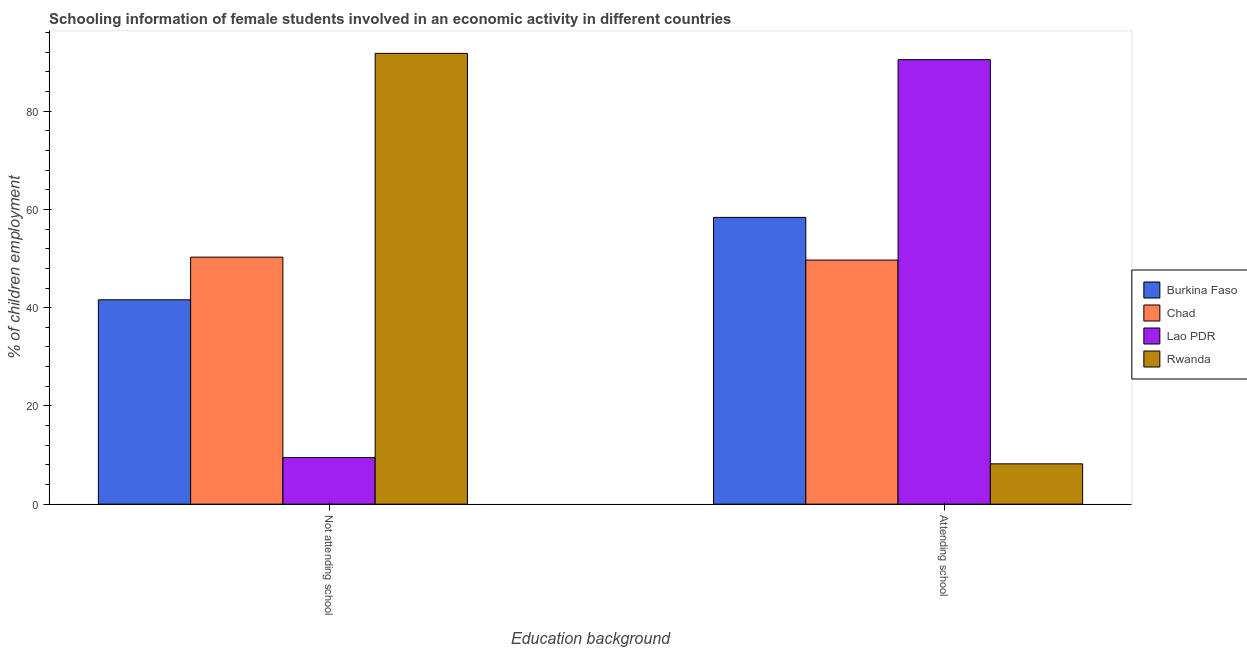How many groups of bars are there?
Ensure brevity in your answer.  2. Are the number of bars per tick equal to the number of legend labels?
Your answer should be compact. Yes. How many bars are there on the 1st tick from the left?
Give a very brief answer. 4. How many bars are there on the 2nd tick from the right?
Offer a very short reply. 4. What is the label of the 2nd group of bars from the left?
Ensure brevity in your answer.  Attending school. What is the percentage of employed females who are not attending school in Rwanda?
Provide a short and direct response. 91.79. Across all countries, what is the maximum percentage of employed females who are not attending school?
Offer a very short reply. 91.79. Across all countries, what is the minimum percentage of employed females who are not attending school?
Your answer should be very brief. 9.49. In which country was the percentage of employed females who are attending school maximum?
Your answer should be compact. Lao PDR. In which country was the percentage of employed females who are attending school minimum?
Offer a very short reply. Rwanda. What is the total percentage of employed females who are not attending school in the graph?
Make the answer very short. 193.19. What is the difference between the percentage of employed females who are not attending school in Chad and that in Lao PDR?
Keep it short and to the point. 40.81. What is the difference between the percentage of employed females who are not attending school in Rwanda and the percentage of employed females who are attending school in Chad?
Keep it short and to the point. 42.09. What is the average percentage of employed females who are not attending school per country?
Offer a terse response. 48.3. What is the difference between the percentage of employed females who are attending school and percentage of employed females who are not attending school in Rwanda?
Your answer should be compact. -83.58. What is the ratio of the percentage of employed females who are attending school in Chad to that in Burkina Faso?
Your answer should be very brief. 0.85. Is the percentage of employed females who are attending school in Lao PDR less than that in Burkina Faso?
Your answer should be very brief. No. What does the 4th bar from the left in Not attending school represents?
Provide a succinct answer. Rwanda. What does the 1st bar from the right in Not attending school represents?
Give a very brief answer. Rwanda. How many countries are there in the graph?
Offer a terse response. 4. Does the graph contain grids?
Ensure brevity in your answer.  No. Where does the legend appear in the graph?
Provide a short and direct response. Center right. How are the legend labels stacked?
Keep it short and to the point. Vertical. What is the title of the graph?
Provide a short and direct response. Schooling information of female students involved in an economic activity in different countries. Does "Saudi Arabia" appear as one of the legend labels in the graph?
Give a very brief answer. No. What is the label or title of the X-axis?
Your response must be concise. Education background. What is the label or title of the Y-axis?
Your answer should be compact. % of children employment. What is the % of children employment of Burkina Faso in Not attending school?
Ensure brevity in your answer.  41.61. What is the % of children employment of Chad in Not attending school?
Your answer should be compact. 50.3. What is the % of children employment in Lao PDR in Not attending school?
Give a very brief answer. 9.49. What is the % of children employment in Rwanda in Not attending school?
Your response must be concise. 91.79. What is the % of children employment of Burkina Faso in Attending school?
Make the answer very short. 58.39. What is the % of children employment in Chad in Attending school?
Ensure brevity in your answer.  49.7. What is the % of children employment of Lao PDR in Attending school?
Your answer should be very brief. 90.51. What is the % of children employment of Rwanda in Attending school?
Make the answer very short. 8.21. Across all Education background, what is the maximum % of children employment of Burkina Faso?
Your answer should be very brief. 58.39. Across all Education background, what is the maximum % of children employment in Chad?
Make the answer very short. 50.3. Across all Education background, what is the maximum % of children employment of Lao PDR?
Your answer should be very brief. 90.51. Across all Education background, what is the maximum % of children employment in Rwanda?
Keep it short and to the point. 91.79. Across all Education background, what is the minimum % of children employment of Burkina Faso?
Your answer should be compact. 41.61. Across all Education background, what is the minimum % of children employment in Chad?
Provide a short and direct response. 49.7. Across all Education background, what is the minimum % of children employment of Lao PDR?
Provide a succinct answer. 9.49. Across all Education background, what is the minimum % of children employment in Rwanda?
Make the answer very short. 8.21. What is the total % of children employment in Burkina Faso in the graph?
Keep it short and to the point. 100. What is the total % of children employment in Chad in the graph?
Keep it short and to the point. 100. What is the difference between the % of children employment in Burkina Faso in Not attending school and that in Attending school?
Your answer should be compact. -16.78. What is the difference between the % of children employment in Lao PDR in Not attending school and that in Attending school?
Your response must be concise. -81.02. What is the difference between the % of children employment of Rwanda in Not attending school and that in Attending school?
Give a very brief answer. 83.58. What is the difference between the % of children employment of Burkina Faso in Not attending school and the % of children employment of Chad in Attending school?
Offer a terse response. -8.09. What is the difference between the % of children employment in Burkina Faso in Not attending school and the % of children employment in Lao PDR in Attending school?
Offer a very short reply. -48.9. What is the difference between the % of children employment of Burkina Faso in Not attending school and the % of children employment of Rwanda in Attending school?
Ensure brevity in your answer.  33.4. What is the difference between the % of children employment of Chad in Not attending school and the % of children employment of Lao PDR in Attending school?
Provide a short and direct response. -40.21. What is the difference between the % of children employment of Chad in Not attending school and the % of children employment of Rwanda in Attending school?
Keep it short and to the point. 42.09. What is the difference between the % of children employment in Lao PDR in Not attending school and the % of children employment in Rwanda in Attending school?
Your answer should be very brief. 1.28. What is the average % of children employment in Burkina Faso per Education background?
Provide a succinct answer. 50. What is the average % of children employment in Chad per Education background?
Your answer should be compact. 50. What is the difference between the % of children employment of Burkina Faso and % of children employment of Chad in Not attending school?
Make the answer very short. -8.69. What is the difference between the % of children employment of Burkina Faso and % of children employment of Lao PDR in Not attending school?
Make the answer very short. 32.12. What is the difference between the % of children employment in Burkina Faso and % of children employment in Rwanda in Not attending school?
Keep it short and to the point. -50.18. What is the difference between the % of children employment of Chad and % of children employment of Lao PDR in Not attending school?
Provide a short and direct response. 40.81. What is the difference between the % of children employment of Chad and % of children employment of Rwanda in Not attending school?
Your response must be concise. -41.49. What is the difference between the % of children employment in Lao PDR and % of children employment in Rwanda in Not attending school?
Your answer should be compact. -82.3. What is the difference between the % of children employment in Burkina Faso and % of children employment in Chad in Attending school?
Ensure brevity in your answer.  8.69. What is the difference between the % of children employment in Burkina Faso and % of children employment in Lao PDR in Attending school?
Make the answer very short. -32.12. What is the difference between the % of children employment of Burkina Faso and % of children employment of Rwanda in Attending school?
Keep it short and to the point. 50.18. What is the difference between the % of children employment in Chad and % of children employment in Lao PDR in Attending school?
Keep it short and to the point. -40.81. What is the difference between the % of children employment of Chad and % of children employment of Rwanda in Attending school?
Give a very brief answer. 41.49. What is the difference between the % of children employment of Lao PDR and % of children employment of Rwanda in Attending school?
Your answer should be very brief. 82.3. What is the ratio of the % of children employment of Burkina Faso in Not attending school to that in Attending school?
Provide a short and direct response. 0.71. What is the ratio of the % of children employment of Chad in Not attending school to that in Attending school?
Your answer should be compact. 1.01. What is the ratio of the % of children employment in Lao PDR in Not attending school to that in Attending school?
Ensure brevity in your answer.  0.1. What is the ratio of the % of children employment in Rwanda in Not attending school to that in Attending school?
Give a very brief answer. 11.18. What is the difference between the highest and the second highest % of children employment of Burkina Faso?
Make the answer very short. 16.78. What is the difference between the highest and the second highest % of children employment of Lao PDR?
Your response must be concise. 81.02. What is the difference between the highest and the second highest % of children employment of Rwanda?
Offer a very short reply. 83.58. What is the difference between the highest and the lowest % of children employment of Burkina Faso?
Your response must be concise. 16.78. What is the difference between the highest and the lowest % of children employment in Lao PDR?
Offer a very short reply. 81.02. What is the difference between the highest and the lowest % of children employment of Rwanda?
Offer a very short reply. 83.58. 